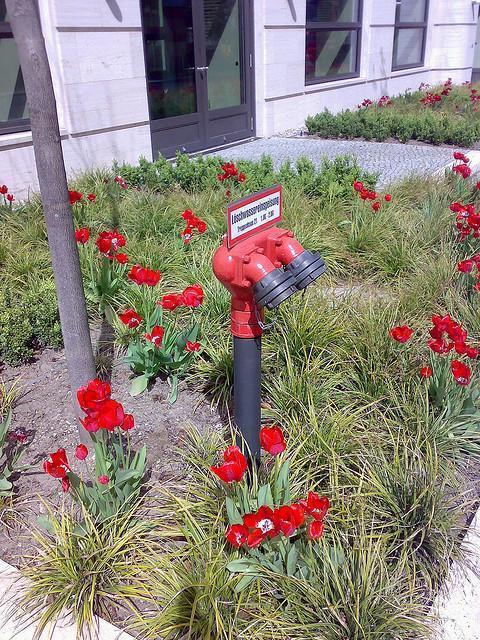How many windows can be seen on the building?
Give a very brief answer. 3. How many elephants are in the picture?
Give a very brief answer. 0. 